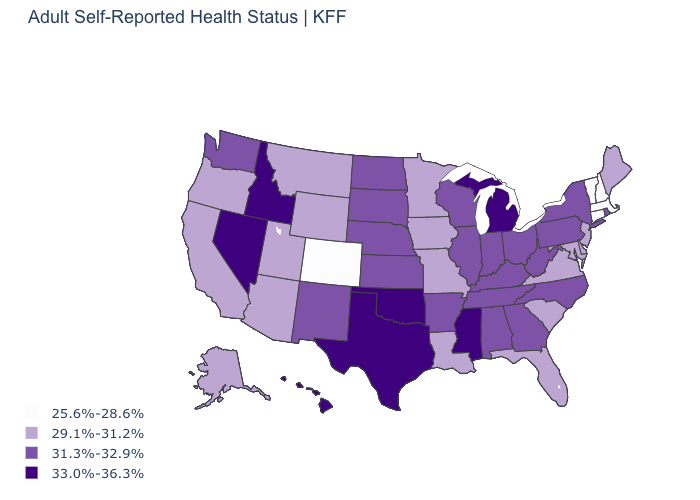What is the value of Mississippi?
Be succinct. 33.0%-36.3%. What is the value of Texas?
Write a very short answer. 33.0%-36.3%. What is the value of Idaho?
Quick response, please. 33.0%-36.3%. Name the states that have a value in the range 25.6%-28.6%?
Write a very short answer. Colorado, Connecticut, Massachusetts, New Hampshire, Vermont. Does the map have missing data?
Write a very short answer. No. Name the states that have a value in the range 33.0%-36.3%?
Be succinct. Hawaii, Idaho, Michigan, Mississippi, Nevada, Oklahoma, Texas. Does North Dakota have a higher value than Massachusetts?
Give a very brief answer. Yes. Which states hav the highest value in the South?
Short answer required. Mississippi, Oklahoma, Texas. What is the value of West Virginia?
Quick response, please. 31.3%-32.9%. Which states hav the highest value in the MidWest?
Keep it brief. Michigan. Name the states that have a value in the range 31.3%-32.9%?
Write a very short answer. Alabama, Arkansas, Georgia, Illinois, Indiana, Kansas, Kentucky, Nebraska, New Mexico, New York, North Carolina, North Dakota, Ohio, Pennsylvania, Rhode Island, South Dakota, Tennessee, Washington, West Virginia, Wisconsin. Name the states that have a value in the range 25.6%-28.6%?
Quick response, please. Colorado, Connecticut, Massachusetts, New Hampshire, Vermont. Name the states that have a value in the range 31.3%-32.9%?
Keep it brief. Alabama, Arkansas, Georgia, Illinois, Indiana, Kansas, Kentucky, Nebraska, New Mexico, New York, North Carolina, North Dakota, Ohio, Pennsylvania, Rhode Island, South Dakota, Tennessee, Washington, West Virginia, Wisconsin. What is the highest value in the South ?
Answer briefly. 33.0%-36.3%. 